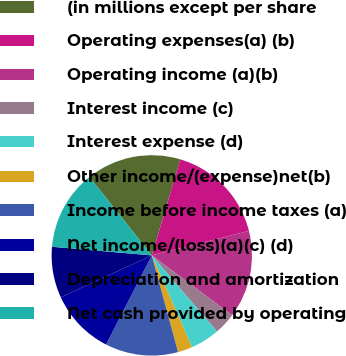<chart> <loc_0><loc_0><loc_500><loc_500><pie_chart><fcel>(in millions except per share<fcel>Operating expenses(a) (b)<fcel>Operating income (a)(b)<fcel>Interest income (c)<fcel>Interest expense (d)<fcel>Other income/(expense)net(b)<fcel>Income before income taxes (a)<fcel>Net income/(loss)(a)(c) (d)<fcel>Depreciation and amortization<fcel>Net cash provided by operating<nl><fcel>15.29%<fcel>16.47%<fcel>14.12%<fcel>3.53%<fcel>4.71%<fcel>2.35%<fcel>11.76%<fcel>10.59%<fcel>8.24%<fcel>12.94%<nl></chart> 